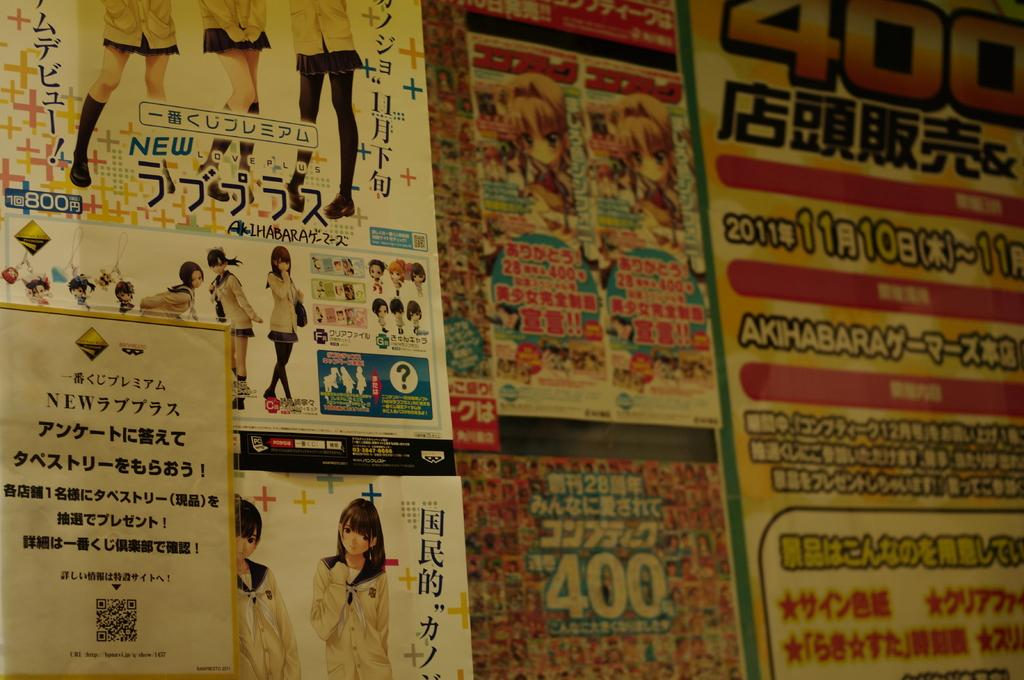<image>
Give a short and clear explanation of the subsequent image. Many of these products are labeled either 400 or 800. 